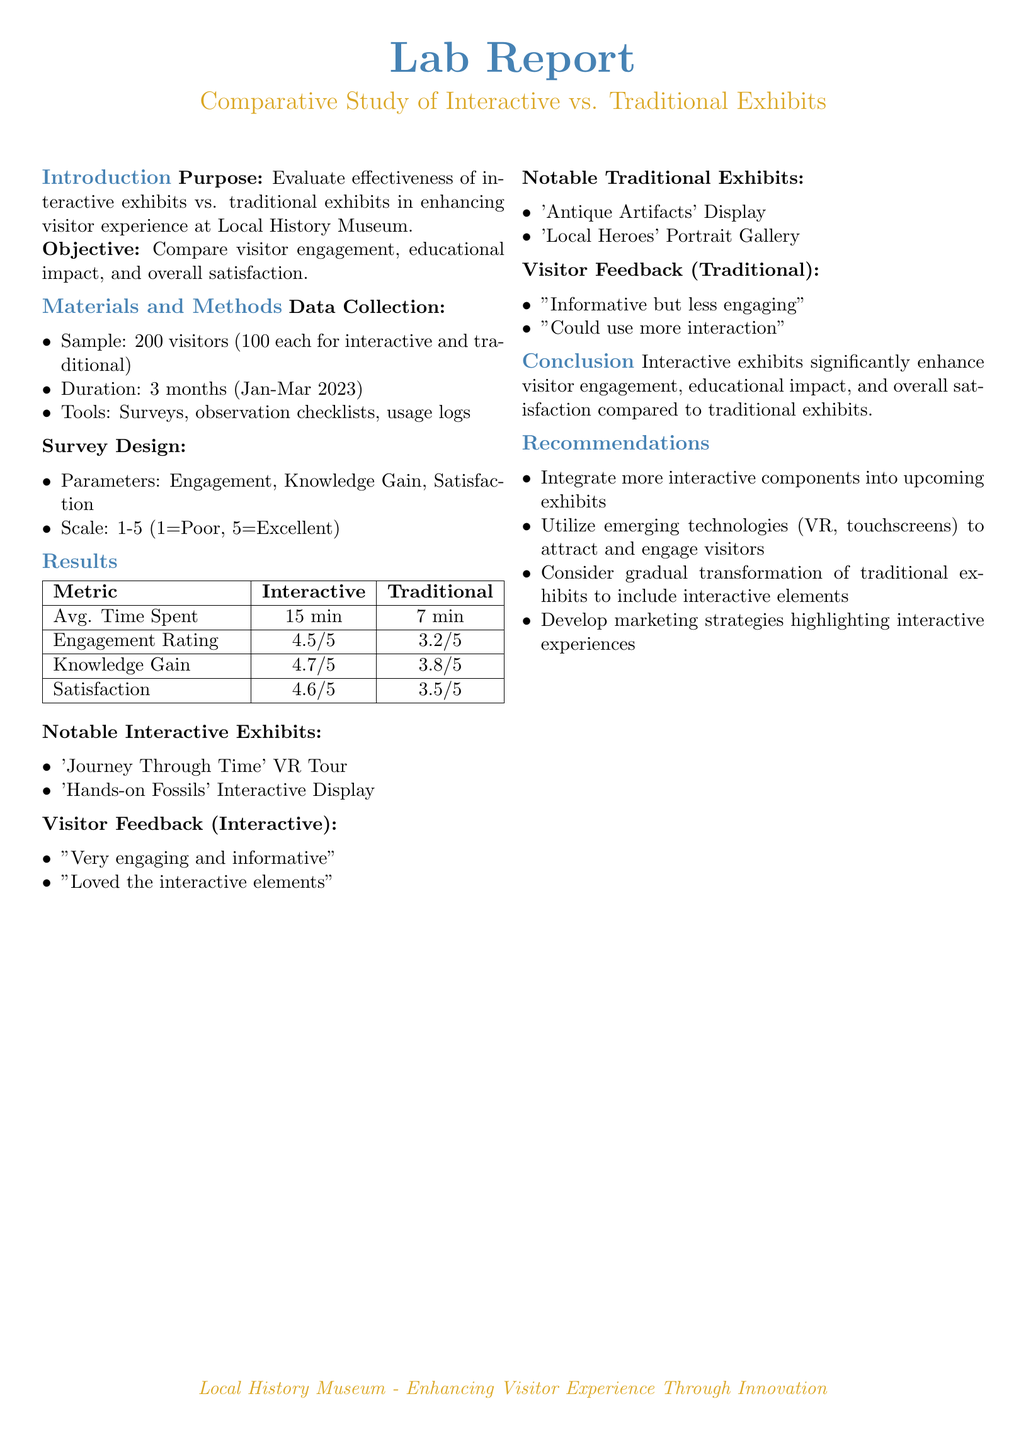What is the sample size for the study? The sample size consists of 200 visitors, with 100 visiting interactive exhibits and 100 visiting traditional exhibits.
Answer: 200 visitors What was the average engagement rating for interactive exhibits? The average engagement rating for interactive exhibits was 4.5 out of 5.
Answer: 4.5/5 What is the knowledge gain rating for traditional exhibits? The knowledge gain rating for traditional exhibits was 3.8 out of 5.
Answer: 3.8/5 What notable interactive exhibit is mentioned in the report? The notable interactive exhibit mentioned is 'Journey Through Time' VR Tour.
Answer: 'Journey Through Time' VR Tour What recommendation is given for upcoming exhibits? The report recommends integrating more interactive components into upcoming exhibits.
Answer: Integrate more interactive components What is the average time spent by visitors on traditional exhibits? Visitors spent an average of 7 minutes on traditional exhibits.
Answer: 7 min What satisfaction rating did interactive exhibits receive? Interactive exhibits received a satisfaction rating of 4.6 out of 5.
Answer: 4.6/5 What was one piece of feedback from visitors regarding traditional exhibits? One piece of feedback was "Could use more interaction".
Answer: "Could use more interaction" What technology does the report suggest using to attract visitors? The report suggests utilizing emerging technologies such as VR and touchscreens.
Answer: VR, touchscreens 